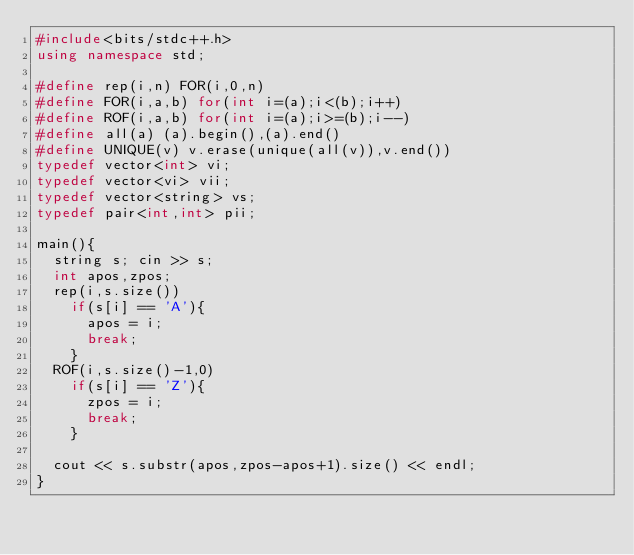Convert code to text. <code><loc_0><loc_0><loc_500><loc_500><_C++_>#include<bits/stdc++.h>
using namespace std;

#define rep(i,n) FOR(i,0,n)
#define FOR(i,a,b) for(int i=(a);i<(b);i++)
#define ROF(i,a,b) for(int i=(a);i>=(b);i--)
#define all(a) (a).begin(),(a).end()
#define UNIQUE(v) v.erase(unique(all(v)),v.end())
typedef vector<int> vi;
typedef vector<vi> vii;
typedef vector<string> vs;
typedef pair<int,int> pii;

main(){
  string s; cin >> s;
  int apos,zpos;
  rep(i,s.size())
    if(s[i] == 'A'){
      apos = i;
      break;
    }
  ROF(i,s.size()-1,0)
    if(s[i] == 'Z'){
      zpos = i;
      break;
    }

  cout << s.substr(apos,zpos-apos+1).size() << endl;
}
</code> 